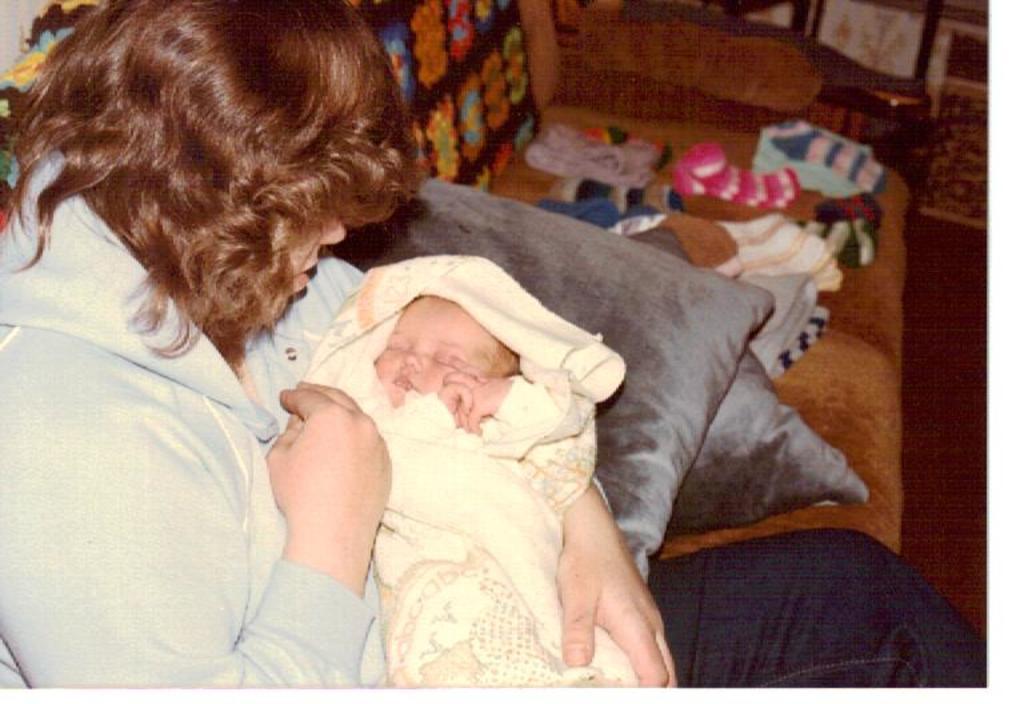Describe this image in one or two sentences. In this image, I can see the woman sitting and holding a baby. These are the cushions. I can see the clothes on the couch. 